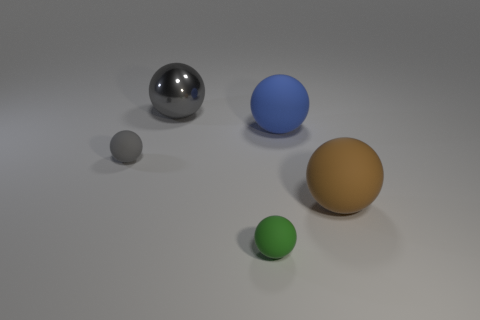Is the number of big balls in front of the small green object less than the number of large cylinders?
Provide a succinct answer. No. Do the small green thing and the gray matte object have the same shape?
Provide a short and direct response. Yes. There is a brown object that is in front of the big gray metal sphere; how big is it?
Your answer should be compact. Large. What size is the gray sphere that is the same material as the green ball?
Offer a very short reply. Small. Is the number of metal objects less than the number of small cylinders?
Ensure brevity in your answer.  No. There is a sphere that is the same size as the green matte object; what is it made of?
Give a very brief answer. Rubber. Are there more big blue objects than big objects?
Your response must be concise. No. What number of other things are there of the same color as the large metal sphere?
Make the answer very short. 1. How many spheres are both behind the tiny gray rubber object and to the left of the blue thing?
Keep it short and to the point. 1. Are there more big gray objects that are to the right of the gray matte sphere than gray rubber things behind the blue rubber sphere?
Offer a terse response. Yes. 